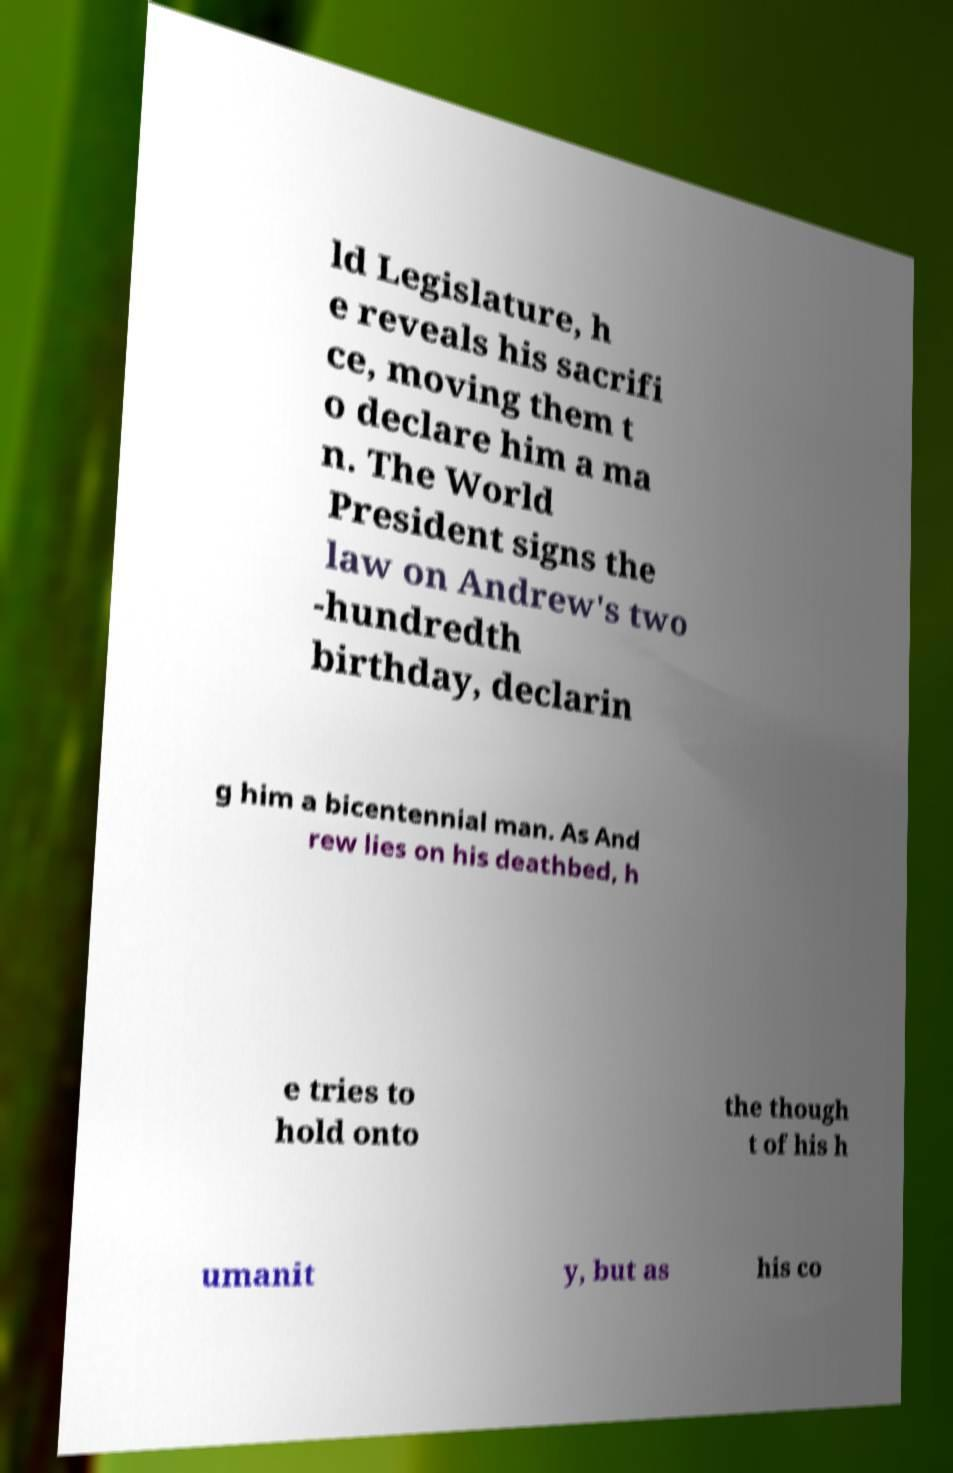What messages or text are displayed in this image? I need them in a readable, typed format. ld Legislature, h e reveals his sacrifi ce, moving them t o declare him a ma n. The World President signs the law on Andrew's two -hundredth birthday, declarin g him a bicentennial man. As And rew lies on his deathbed, h e tries to hold onto the though t of his h umanit y, but as his co 